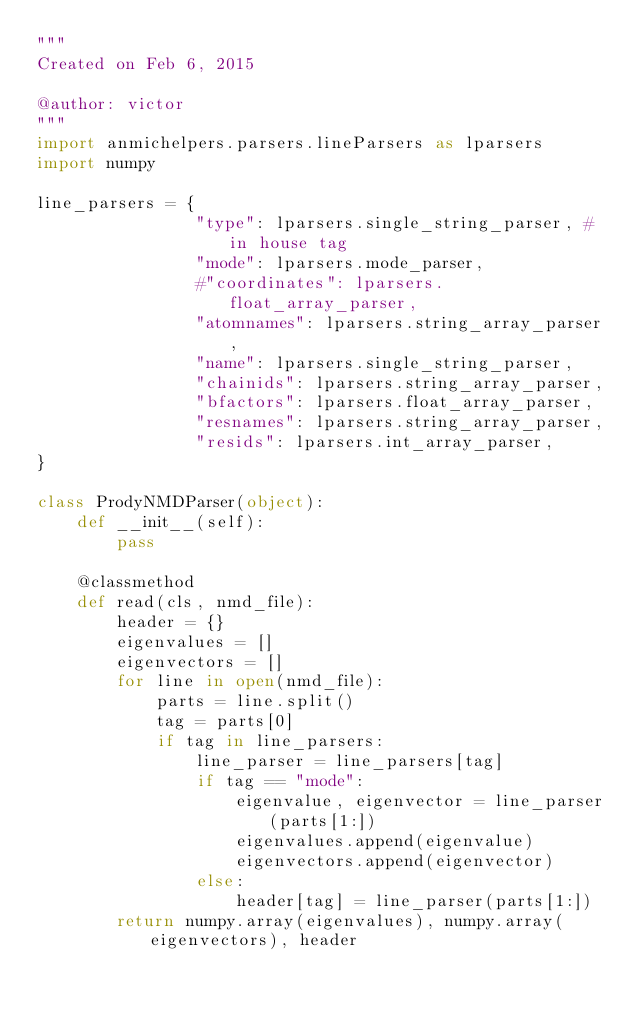<code> <loc_0><loc_0><loc_500><loc_500><_Python_>"""
Created on Feb 6, 2015

@author: victor
"""
import anmichelpers.parsers.lineParsers as lparsers
import numpy

line_parsers = {
                "type": lparsers.single_string_parser, # in house tag
                "mode": lparsers.mode_parser,
                #"coordinates": lparsers.float_array_parser,
                "atomnames": lparsers.string_array_parser,
                "name": lparsers.single_string_parser,
                "chainids": lparsers.string_array_parser,
                "bfactors": lparsers.float_array_parser,
                "resnames": lparsers.string_array_parser,
                "resids": lparsers.int_array_parser,
}

class ProdyNMDParser(object):
    def __init__(self):
        pass
    
    @classmethod
    def read(cls, nmd_file):
        header = {}
        eigenvalues = []
        eigenvectors = []
        for line in open(nmd_file):
            parts = line.split()
            tag = parts[0]
            if tag in line_parsers:
                line_parser = line_parsers[tag]
                if tag == "mode":
                    eigenvalue, eigenvector = line_parser(parts[1:])
                    eigenvalues.append(eigenvalue)
                    eigenvectors.append(eigenvector)
                else:
                    header[tag] = line_parser(parts[1:])
        return numpy.array(eigenvalues), numpy.array(eigenvectors), header
        </code> 